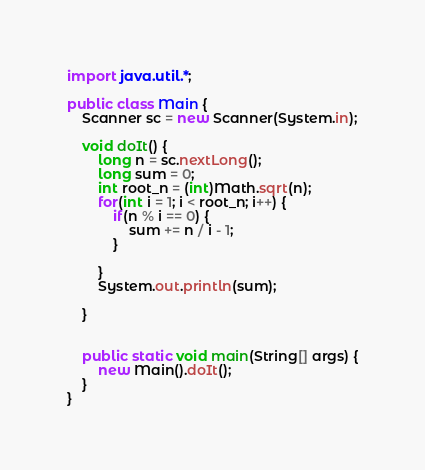Convert code to text. <code><loc_0><loc_0><loc_500><loc_500><_Java_>import java.util.*;

public class Main {
	Scanner sc = new Scanner(System.in);

	void doIt() {
		long n = sc.nextLong();
		long sum = 0;
		int root_n = (int)Math.sqrt(n);
		for(int i = 1; i < root_n; i++) {
			if(n % i == 0) {
				sum += n / i - 1;
			}
			
		}
		System.out.println(sum);
		
	}
	
	
	public static void main(String[] args) {
		new Main().doIt();
	}
}
</code> 